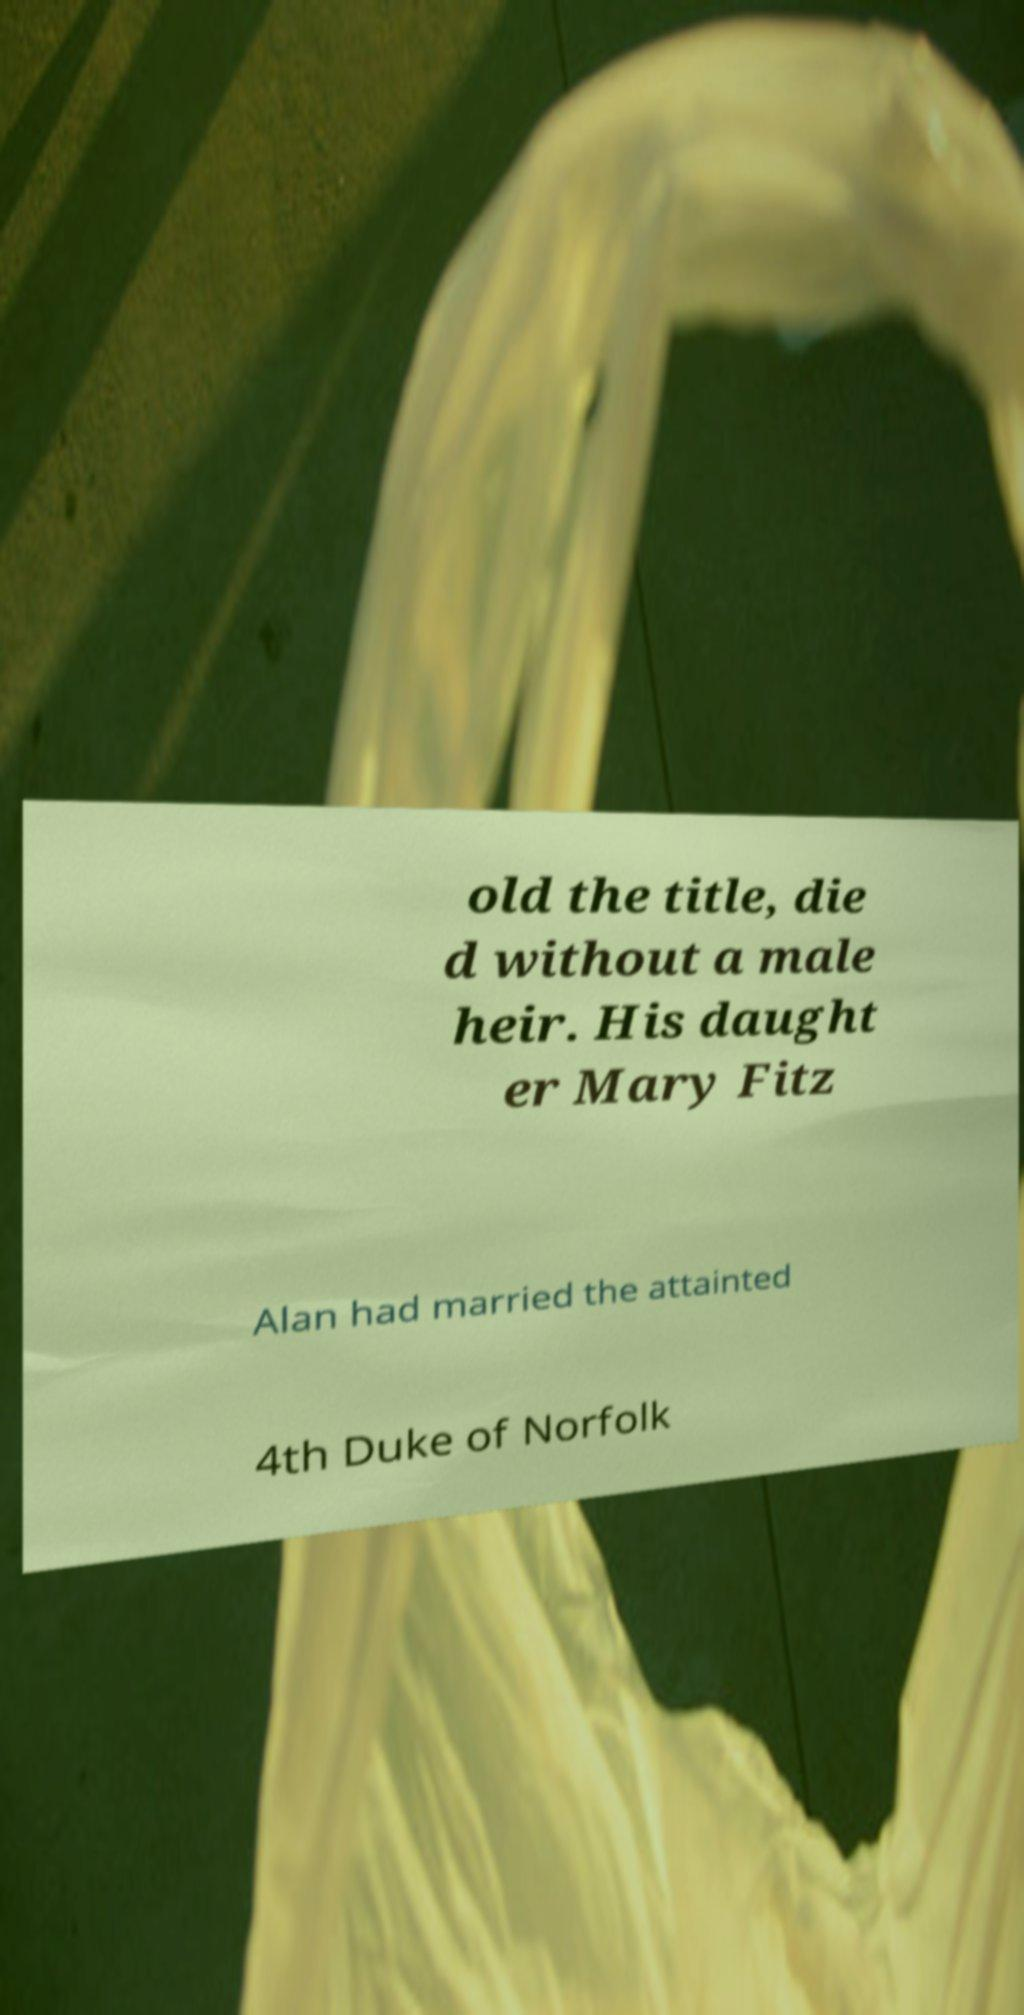I need the written content from this picture converted into text. Can you do that? old the title, die d without a male heir. His daught er Mary Fitz Alan had married the attainted 4th Duke of Norfolk 